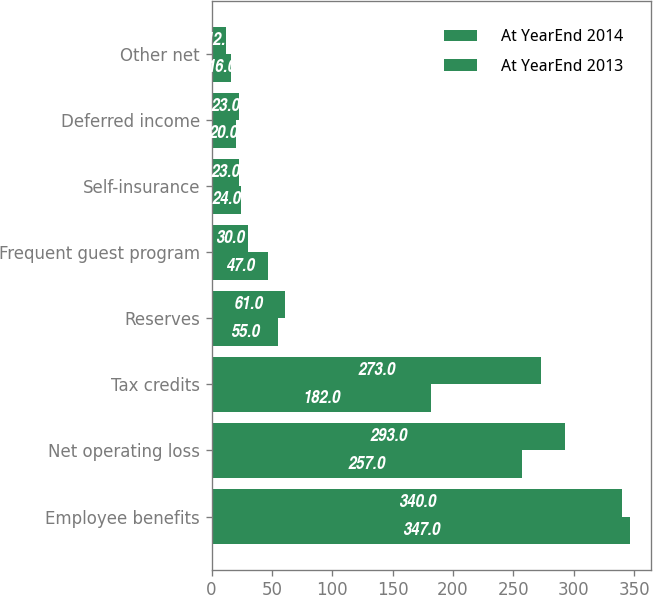Convert chart to OTSL. <chart><loc_0><loc_0><loc_500><loc_500><stacked_bar_chart><ecel><fcel>Employee benefits<fcel>Net operating loss<fcel>Tax credits<fcel>Reserves<fcel>Frequent guest program<fcel>Self-insurance<fcel>Deferred income<fcel>Other net<nl><fcel>At YearEnd 2014<fcel>347<fcel>257<fcel>182<fcel>55<fcel>47<fcel>24<fcel>20<fcel>16<nl><fcel>At YearEnd 2013<fcel>340<fcel>293<fcel>273<fcel>61<fcel>30<fcel>23<fcel>23<fcel>12<nl></chart> 